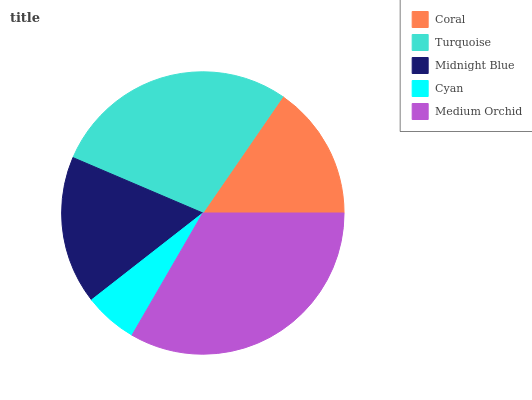Is Cyan the minimum?
Answer yes or no. Yes. Is Medium Orchid the maximum?
Answer yes or no. Yes. Is Turquoise the minimum?
Answer yes or no. No. Is Turquoise the maximum?
Answer yes or no. No. Is Turquoise greater than Coral?
Answer yes or no. Yes. Is Coral less than Turquoise?
Answer yes or no. Yes. Is Coral greater than Turquoise?
Answer yes or no. No. Is Turquoise less than Coral?
Answer yes or no. No. Is Midnight Blue the high median?
Answer yes or no. Yes. Is Midnight Blue the low median?
Answer yes or no. Yes. Is Cyan the high median?
Answer yes or no. No. Is Turquoise the low median?
Answer yes or no. No. 